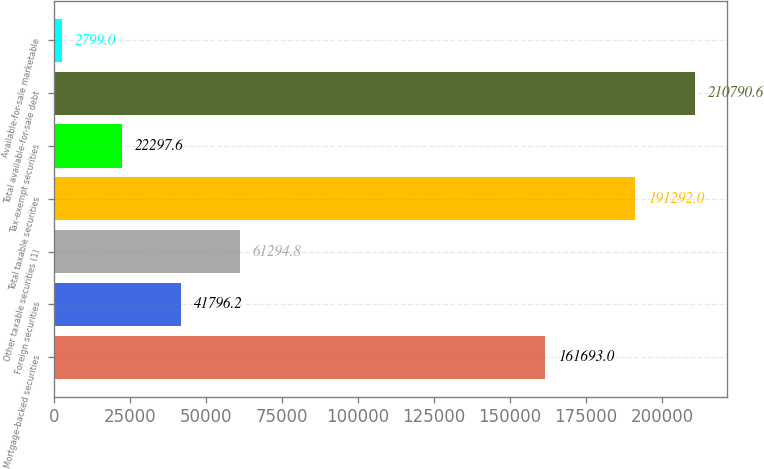Convert chart. <chart><loc_0><loc_0><loc_500><loc_500><bar_chart><fcel>Mortgage-backed securities<fcel>Foreign securities<fcel>Other taxable securities (1)<fcel>Total taxable securities<fcel>Tax-exempt securities<fcel>Total available-for-sale debt<fcel>Available-for-sale marketable<nl><fcel>161693<fcel>41796.2<fcel>61294.8<fcel>191292<fcel>22297.6<fcel>210791<fcel>2799<nl></chart> 